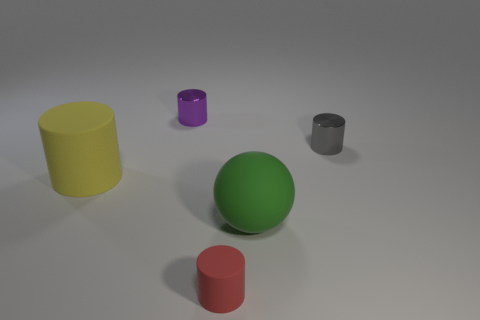Subtract 2 cylinders. How many cylinders are left? 2 Subtract all tiny red cylinders. How many cylinders are left? 3 Subtract all yellow cylinders. How many cylinders are left? 3 Add 5 large gray rubber blocks. How many objects exist? 10 Subtract all purple cylinders. Subtract all gray balls. How many cylinders are left? 3 Subtract all spheres. How many objects are left? 4 Add 2 small purple metal objects. How many small purple metal objects are left? 3 Add 3 small metallic cubes. How many small metallic cubes exist? 3 Subtract 0 cyan cubes. How many objects are left? 5 Subtract all large yellow metallic balls. Subtract all gray metal things. How many objects are left? 4 